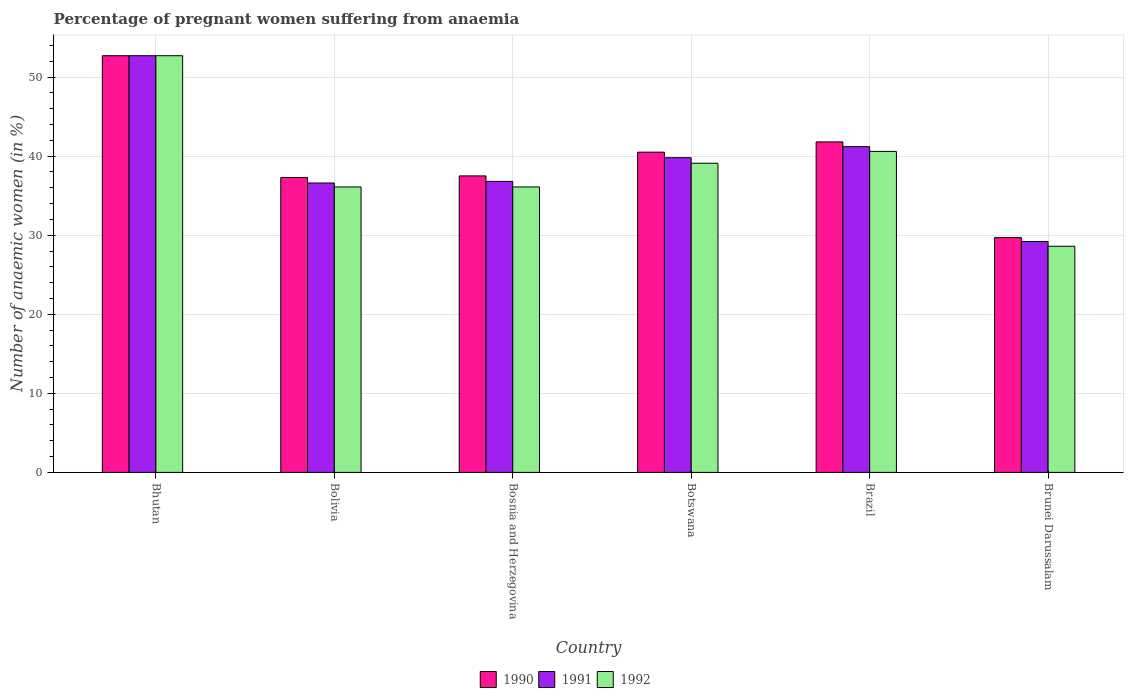How many different coloured bars are there?
Offer a very short reply. 3. Are the number of bars per tick equal to the number of legend labels?
Your answer should be compact. Yes. How many bars are there on the 6th tick from the left?
Offer a terse response. 3. What is the label of the 4th group of bars from the left?
Your answer should be very brief. Botswana. In how many cases, is the number of bars for a given country not equal to the number of legend labels?
Keep it short and to the point. 0. What is the number of anaemic women in 1991 in Brazil?
Your answer should be very brief. 41.2. Across all countries, what is the maximum number of anaemic women in 1991?
Provide a succinct answer. 52.7. Across all countries, what is the minimum number of anaemic women in 1990?
Ensure brevity in your answer.  29.7. In which country was the number of anaemic women in 1991 maximum?
Make the answer very short. Bhutan. In which country was the number of anaemic women in 1991 minimum?
Ensure brevity in your answer.  Brunei Darussalam. What is the total number of anaemic women in 1992 in the graph?
Offer a terse response. 233.2. What is the difference between the number of anaemic women in 1992 in Bhutan and that in Botswana?
Your answer should be very brief. 13.6. What is the average number of anaemic women in 1990 per country?
Keep it short and to the point. 39.92. What is the difference between the number of anaemic women of/in 1991 and number of anaemic women of/in 1992 in Botswana?
Keep it short and to the point. 0.7. In how many countries, is the number of anaemic women in 1991 greater than 42 %?
Offer a terse response. 1. What is the ratio of the number of anaemic women in 1992 in Bhutan to that in Bolivia?
Keep it short and to the point. 1.46. What is the difference between the highest and the second highest number of anaemic women in 1992?
Give a very brief answer. -12.1. What is the difference between the highest and the lowest number of anaemic women in 1991?
Offer a very short reply. 23.5. Is it the case that in every country, the sum of the number of anaemic women in 1992 and number of anaemic women in 1990 is greater than the number of anaemic women in 1991?
Keep it short and to the point. Yes. How many bars are there?
Keep it short and to the point. 18. Are all the bars in the graph horizontal?
Your response must be concise. No. How many countries are there in the graph?
Your answer should be very brief. 6. What is the difference between two consecutive major ticks on the Y-axis?
Offer a very short reply. 10. Does the graph contain grids?
Offer a terse response. Yes. Where does the legend appear in the graph?
Offer a terse response. Bottom center. How many legend labels are there?
Keep it short and to the point. 3. How are the legend labels stacked?
Provide a short and direct response. Horizontal. What is the title of the graph?
Give a very brief answer. Percentage of pregnant women suffering from anaemia. Does "1999" appear as one of the legend labels in the graph?
Offer a very short reply. No. What is the label or title of the Y-axis?
Offer a very short reply. Number of anaemic women (in %). What is the Number of anaemic women (in %) in 1990 in Bhutan?
Your answer should be very brief. 52.7. What is the Number of anaemic women (in %) of 1991 in Bhutan?
Your response must be concise. 52.7. What is the Number of anaemic women (in %) in 1992 in Bhutan?
Provide a succinct answer. 52.7. What is the Number of anaemic women (in %) of 1990 in Bolivia?
Your answer should be very brief. 37.3. What is the Number of anaemic women (in %) in 1991 in Bolivia?
Give a very brief answer. 36.6. What is the Number of anaemic women (in %) in 1992 in Bolivia?
Offer a terse response. 36.1. What is the Number of anaemic women (in %) in 1990 in Bosnia and Herzegovina?
Keep it short and to the point. 37.5. What is the Number of anaemic women (in %) of 1991 in Bosnia and Herzegovina?
Provide a short and direct response. 36.8. What is the Number of anaemic women (in %) in 1992 in Bosnia and Herzegovina?
Provide a succinct answer. 36.1. What is the Number of anaemic women (in %) of 1990 in Botswana?
Your response must be concise. 40.5. What is the Number of anaemic women (in %) of 1991 in Botswana?
Offer a terse response. 39.8. What is the Number of anaemic women (in %) of 1992 in Botswana?
Your answer should be compact. 39.1. What is the Number of anaemic women (in %) in 1990 in Brazil?
Offer a very short reply. 41.8. What is the Number of anaemic women (in %) of 1991 in Brazil?
Give a very brief answer. 41.2. What is the Number of anaemic women (in %) in 1992 in Brazil?
Provide a short and direct response. 40.6. What is the Number of anaemic women (in %) in 1990 in Brunei Darussalam?
Offer a very short reply. 29.7. What is the Number of anaemic women (in %) of 1991 in Brunei Darussalam?
Ensure brevity in your answer.  29.2. What is the Number of anaemic women (in %) of 1992 in Brunei Darussalam?
Ensure brevity in your answer.  28.6. Across all countries, what is the maximum Number of anaemic women (in %) of 1990?
Your answer should be very brief. 52.7. Across all countries, what is the maximum Number of anaemic women (in %) in 1991?
Provide a succinct answer. 52.7. Across all countries, what is the maximum Number of anaemic women (in %) of 1992?
Offer a terse response. 52.7. Across all countries, what is the minimum Number of anaemic women (in %) in 1990?
Offer a very short reply. 29.7. Across all countries, what is the minimum Number of anaemic women (in %) of 1991?
Give a very brief answer. 29.2. Across all countries, what is the minimum Number of anaemic women (in %) in 1992?
Your answer should be very brief. 28.6. What is the total Number of anaemic women (in %) of 1990 in the graph?
Ensure brevity in your answer.  239.5. What is the total Number of anaemic women (in %) of 1991 in the graph?
Offer a terse response. 236.3. What is the total Number of anaemic women (in %) of 1992 in the graph?
Offer a very short reply. 233.2. What is the difference between the Number of anaemic women (in %) in 1991 in Bhutan and that in Bolivia?
Provide a short and direct response. 16.1. What is the difference between the Number of anaemic women (in %) in 1990 in Bhutan and that in Bosnia and Herzegovina?
Offer a terse response. 15.2. What is the difference between the Number of anaemic women (in %) of 1990 in Bhutan and that in Botswana?
Offer a very short reply. 12.2. What is the difference between the Number of anaemic women (in %) in 1991 in Bhutan and that in Brazil?
Give a very brief answer. 11.5. What is the difference between the Number of anaemic women (in %) of 1992 in Bhutan and that in Brazil?
Keep it short and to the point. 12.1. What is the difference between the Number of anaemic women (in %) of 1990 in Bhutan and that in Brunei Darussalam?
Offer a very short reply. 23. What is the difference between the Number of anaemic women (in %) in 1992 in Bhutan and that in Brunei Darussalam?
Your response must be concise. 24.1. What is the difference between the Number of anaemic women (in %) in 1992 in Bolivia and that in Bosnia and Herzegovina?
Your response must be concise. 0. What is the difference between the Number of anaemic women (in %) of 1992 in Bolivia and that in Botswana?
Offer a terse response. -3. What is the difference between the Number of anaemic women (in %) of 1990 in Bolivia and that in Brazil?
Provide a succinct answer. -4.5. What is the difference between the Number of anaemic women (in %) in 1991 in Bolivia and that in Brazil?
Your answer should be very brief. -4.6. What is the difference between the Number of anaemic women (in %) of 1992 in Bolivia and that in Brazil?
Keep it short and to the point. -4.5. What is the difference between the Number of anaemic women (in %) of 1990 in Bolivia and that in Brunei Darussalam?
Give a very brief answer. 7.6. What is the difference between the Number of anaemic women (in %) in 1992 in Bolivia and that in Brunei Darussalam?
Offer a very short reply. 7.5. What is the difference between the Number of anaemic women (in %) in 1991 in Bosnia and Herzegovina and that in Botswana?
Give a very brief answer. -3. What is the difference between the Number of anaemic women (in %) of 1990 in Bosnia and Herzegovina and that in Brazil?
Give a very brief answer. -4.3. What is the difference between the Number of anaemic women (in %) of 1991 in Bosnia and Herzegovina and that in Brazil?
Your response must be concise. -4.4. What is the difference between the Number of anaemic women (in %) in 1992 in Bosnia and Herzegovina and that in Brunei Darussalam?
Give a very brief answer. 7.5. What is the difference between the Number of anaemic women (in %) in 1990 in Botswana and that in Brazil?
Provide a succinct answer. -1.3. What is the difference between the Number of anaemic women (in %) in 1991 in Botswana and that in Brazil?
Offer a terse response. -1.4. What is the difference between the Number of anaemic women (in %) of 1990 in Botswana and that in Brunei Darussalam?
Offer a very short reply. 10.8. What is the difference between the Number of anaemic women (in %) in 1991 in Botswana and that in Brunei Darussalam?
Your answer should be very brief. 10.6. What is the difference between the Number of anaemic women (in %) in 1991 in Brazil and that in Brunei Darussalam?
Your answer should be compact. 12. What is the difference between the Number of anaemic women (in %) in 1990 in Bhutan and the Number of anaemic women (in %) in 1991 in Bolivia?
Make the answer very short. 16.1. What is the difference between the Number of anaemic women (in %) of 1990 in Bhutan and the Number of anaemic women (in %) of 1992 in Bolivia?
Offer a very short reply. 16.6. What is the difference between the Number of anaemic women (in %) of 1991 in Bhutan and the Number of anaemic women (in %) of 1992 in Bolivia?
Offer a terse response. 16.6. What is the difference between the Number of anaemic women (in %) in 1991 in Bhutan and the Number of anaemic women (in %) in 1992 in Bosnia and Herzegovina?
Keep it short and to the point. 16.6. What is the difference between the Number of anaemic women (in %) of 1990 in Bhutan and the Number of anaemic women (in %) of 1991 in Brazil?
Provide a short and direct response. 11.5. What is the difference between the Number of anaemic women (in %) in 1990 in Bhutan and the Number of anaemic women (in %) in 1991 in Brunei Darussalam?
Your response must be concise. 23.5. What is the difference between the Number of anaemic women (in %) in 1990 in Bhutan and the Number of anaemic women (in %) in 1992 in Brunei Darussalam?
Offer a very short reply. 24.1. What is the difference between the Number of anaemic women (in %) in 1991 in Bhutan and the Number of anaemic women (in %) in 1992 in Brunei Darussalam?
Provide a succinct answer. 24.1. What is the difference between the Number of anaemic women (in %) of 1991 in Bolivia and the Number of anaemic women (in %) of 1992 in Bosnia and Herzegovina?
Provide a succinct answer. 0.5. What is the difference between the Number of anaemic women (in %) in 1990 in Bolivia and the Number of anaemic women (in %) in 1992 in Botswana?
Provide a short and direct response. -1.8. What is the difference between the Number of anaemic women (in %) of 1991 in Bolivia and the Number of anaemic women (in %) of 1992 in Botswana?
Ensure brevity in your answer.  -2.5. What is the difference between the Number of anaemic women (in %) in 1990 in Bolivia and the Number of anaemic women (in %) in 1992 in Brazil?
Your response must be concise. -3.3. What is the difference between the Number of anaemic women (in %) in 1991 in Bolivia and the Number of anaemic women (in %) in 1992 in Brazil?
Provide a succinct answer. -4. What is the difference between the Number of anaemic women (in %) of 1990 in Bolivia and the Number of anaemic women (in %) of 1992 in Brunei Darussalam?
Your response must be concise. 8.7. What is the difference between the Number of anaemic women (in %) in 1991 in Bolivia and the Number of anaemic women (in %) in 1992 in Brunei Darussalam?
Provide a short and direct response. 8. What is the difference between the Number of anaemic women (in %) in 1990 in Bosnia and Herzegovina and the Number of anaemic women (in %) in 1991 in Botswana?
Ensure brevity in your answer.  -2.3. What is the difference between the Number of anaemic women (in %) in 1990 in Bosnia and Herzegovina and the Number of anaemic women (in %) in 1991 in Brazil?
Your response must be concise. -3.7. What is the difference between the Number of anaemic women (in %) in 1990 in Botswana and the Number of anaemic women (in %) in 1992 in Brazil?
Provide a succinct answer. -0.1. What is the difference between the Number of anaemic women (in %) in 1991 in Botswana and the Number of anaemic women (in %) in 1992 in Brazil?
Provide a succinct answer. -0.8. What is the difference between the Number of anaemic women (in %) of 1990 in Botswana and the Number of anaemic women (in %) of 1991 in Brunei Darussalam?
Ensure brevity in your answer.  11.3. What is the difference between the Number of anaemic women (in %) in 1990 in Brazil and the Number of anaemic women (in %) in 1991 in Brunei Darussalam?
Offer a very short reply. 12.6. What is the difference between the Number of anaemic women (in %) in 1990 in Brazil and the Number of anaemic women (in %) in 1992 in Brunei Darussalam?
Ensure brevity in your answer.  13.2. What is the difference between the Number of anaemic women (in %) in 1991 in Brazil and the Number of anaemic women (in %) in 1992 in Brunei Darussalam?
Your answer should be very brief. 12.6. What is the average Number of anaemic women (in %) in 1990 per country?
Make the answer very short. 39.92. What is the average Number of anaemic women (in %) in 1991 per country?
Provide a short and direct response. 39.38. What is the average Number of anaemic women (in %) in 1992 per country?
Give a very brief answer. 38.87. What is the difference between the Number of anaemic women (in %) of 1990 and Number of anaemic women (in %) of 1991 in Bhutan?
Provide a short and direct response. 0. What is the difference between the Number of anaemic women (in %) in 1991 and Number of anaemic women (in %) in 1992 in Bhutan?
Provide a succinct answer. 0. What is the difference between the Number of anaemic women (in %) in 1990 and Number of anaemic women (in %) in 1992 in Bolivia?
Offer a terse response. 1.2. What is the difference between the Number of anaemic women (in %) in 1991 and Number of anaemic women (in %) in 1992 in Bolivia?
Give a very brief answer. 0.5. What is the difference between the Number of anaemic women (in %) of 1990 and Number of anaemic women (in %) of 1992 in Botswana?
Your answer should be compact. 1.4. What is the difference between the Number of anaemic women (in %) of 1990 and Number of anaemic women (in %) of 1992 in Brazil?
Your answer should be very brief. 1.2. What is the difference between the Number of anaemic women (in %) of 1990 and Number of anaemic women (in %) of 1992 in Brunei Darussalam?
Provide a succinct answer. 1.1. What is the ratio of the Number of anaemic women (in %) of 1990 in Bhutan to that in Bolivia?
Your answer should be compact. 1.41. What is the ratio of the Number of anaemic women (in %) of 1991 in Bhutan to that in Bolivia?
Your answer should be compact. 1.44. What is the ratio of the Number of anaemic women (in %) of 1992 in Bhutan to that in Bolivia?
Your answer should be compact. 1.46. What is the ratio of the Number of anaemic women (in %) of 1990 in Bhutan to that in Bosnia and Herzegovina?
Provide a succinct answer. 1.41. What is the ratio of the Number of anaemic women (in %) in 1991 in Bhutan to that in Bosnia and Herzegovina?
Provide a succinct answer. 1.43. What is the ratio of the Number of anaemic women (in %) in 1992 in Bhutan to that in Bosnia and Herzegovina?
Your response must be concise. 1.46. What is the ratio of the Number of anaemic women (in %) of 1990 in Bhutan to that in Botswana?
Provide a short and direct response. 1.3. What is the ratio of the Number of anaemic women (in %) in 1991 in Bhutan to that in Botswana?
Provide a succinct answer. 1.32. What is the ratio of the Number of anaemic women (in %) in 1992 in Bhutan to that in Botswana?
Your answer should be compact. 1.35. What is the ratio of the Number of anaemic women (in %) in 1990 in Bhutan to that in Brazil?
Your answer should be very brief. 1.26. What is the ratio of the Number of anaemic women (in %) in 1991 in Bhutan to that in Brazil?
Provide a succinct answer. 1.28. What is the ratio of the Number of anaemic women (in %) in 1992 in Bhutan to that in Brazil?
Make the answer very short. 1.3. What is the ratio of the Number of anaemic women (in %) of 1990 in Bhutan to that in Brunei Darussalam?
Give a very brief answer. 1.77. What is the ratio of the Number of anaemic women (in %) in 1991 in Bhutan to that in Brunei Darussalam?
Make the answer very short. 1.8. What is the ratio of the Number of anaemic women (in %) of 1992 in Bhutan to that in Brunei Darussalam?
Provide a succinct answer. 1.84. What is the ratio of the Number of anaemic women (in %) in 1992 in Bolivia to that in Bosnia and Herzegovina?
Make the answer very short. 1. What is the ratio of the Number of anaemic women (in %) in 1990 in Bolivia to that in Botswana?
Provide a short and direct response. 0.92. What is the ratio of the Number of anaemic women (in %) of 1991 in Bolivia to that in Botswana?
Give a very brief answer. 0.92. What is the ratio of the Number of anaemic women (in %) of 1992 in Bolivia to that in Botswana?
Your answer should be compact. 0.92. What is the ratio of the Number of anaemic women (in %) in 1990 in Bolivia to that in Brazil?
Ensure brevity in your answer.  0.89. What is the ratio of the Number of anaemic women (in %) of 1991 in Bolivia to that in Brazil?
Your response must be concise. 0.89. What is the ratio of the Number of anaemic women (in %) of 1992 in Bolivia to that in Brazil?
Provide a succinct answer. 0.89. What is the ratio of the Number of anaemic women (in %) of 1990 in Bolivia to that in Brunei Darussalam?
Your answer should be very brief. 1.26. What is the ratio of the Number of anaemic women (in %) of 1991 in Bolivia to that in Brunei Darussalam?
Offer a terse response. 1.25. What is the ratio of the Number of anaemic women (in %) of 1992 in Bolivia to that in Brunei Darussalam?
Ensure brevity in your answer.  1.26. What is the ratio of the Number of anaemic women (in %) in 1990 in Bosnia and Herzegovina to that in Botswana?
Your response must be concise. 0.93. What is the ratio of the Number of anaemic women (in %) of 1991 in Bosnia and Herzegovina to that in Botswana?
Ensure brevity in your answer.  0.92. What is the ratio of the Number of anaemic women (in %) in 1992 in Bosnia and Herzegovina to that in Botswana?
Keep it short and to the point. 0.92. What is the ratio of the Number of anaemic women (in %) of 1990 in Bosnia and Herzegovina to that in Brazil?
Your response must be concise. 0.9. What is the ratio of the Number of anaemic women (in %) in 1991 in Bosnia and Herzegovina to that in Brazil?
Offer a terse response. 0.89. What is the ratio of the Number of anaemic women (in %) of 1992 in Bosnia and Herzegovina to that in Brazil?
Make the answer very short. 0.89. What is the ratio of the Number of anaemic women (in %) of 1990 in Bosnia and Herzegovina to that in Brunei Darussalam?
Your answer should be compact. 1.26. What is the ratio of the Number of anaemic women (in %) of 1991 in Bosnia and Herzegovina to that in Brunei Darussalam?
Your answer should be very brief. 1.26. What is the ratio of the Number of anaemic women (in %) in 1992 in Bosnia and Herzegovina to that in Brunei Darussalam?
Offer a terse response. 1.26. What is the ratio of the Number of anaemic women (in %) in 1990 in Botswana to that in Brazil?
Provide a short and direct response. 0.97. What is the ratio of the Number of anaemic women (in %) in 1992 in Botswana to that in Brazil?
Keep it short and to the point. 0.96. What is the ratio of the Number of anaemic women (in %) in 1990 in Botswana to that in Brunei Darussalam?
Give a very brief answer. 1.36. What is the ratio of the Number of anaemic women (in %) in 1991 in Botswana to that in Brunei Darussalam?
Make the answer very short. 1.36. What is the ratio of the Number of anaemic women (in %) of 1992 in Botswana to that in Brunei Darussalam?
Your answer should be compact. 1.37. What is the ratio of the Number of anaemic women (in %) of 1990 in Brazil to that in Brunei Darussalam?
Ensure brevity in your answer.  1.41. What is the ratio of the Number of anaemic women (in %) of 1991 in Brazil to that in Brunei Darussalam?
Give a very brief answer. 1.41. What is the ratio of the Number of anaemic women (in %) of 1992 in Brazil to that in Brunei Darussalam?
Your response must be concise. 1.42. What is the difference between the highest and the second highest Number of anaemic women (in %) in 1990?
Your answer should be compact. 10.9. What is the difference between the highest and the second highest Number of anaemic women (in %) of 1991?
Keep it short and to the point. 11.5. What is the difference between the highest and the lowest Number of anaemic women (in %) in 1991?
Your answer should be compact. 23.5. What is the difference between the highest and the lowest Number of anaemic women (in %) of 1992?
Give a very brief answer. 24.1. 